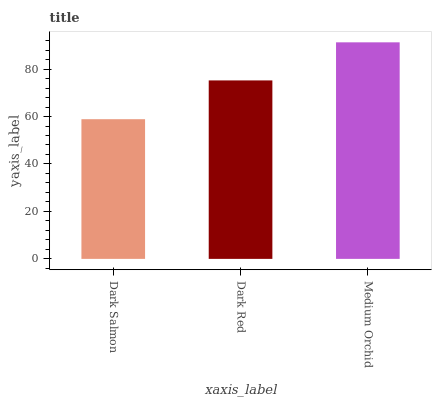Is Medium Orchid the maximum?
Answer yes or no. Yes. Is Dark Red the minimum?
Answer yes or no. No. Is Dark Red the maximum?
Answer yes or no. No. Is Dark Red greater than Dark Salmon?
Answer yes or no. Yes. Is Dark Salmon less than Dark Red?
Answer yes or no. Yes. Is Dark Salmon greater than Dark Red?
Answer yes or no. No. Is Dark Red less than Dark Salmon?
Answer yes or no. No. Is Dark Red the high median?
Answer yes or no. Yes. Is Dark Red the low median?
Answer yes or no. Yes. Is Medium Orchid the high median?
Answer yes or no. No. Is Dark Salmon the low median?
Answer yes or no. No. 